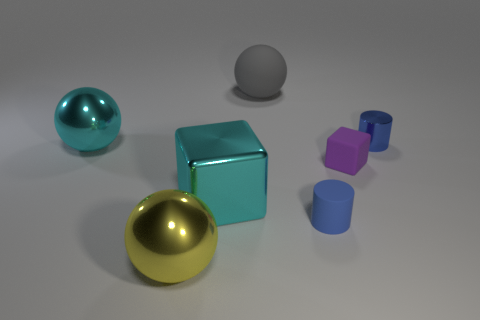Is there a small cylinder that has the same material as the purple block?
Your answer should be very brief. Yes. What is the shape of the yellow object?
Make the answer very short. Sphere. How many purple matte objects are there?
Offer a terse response. 1. What is the color of the tiny cylinder in front of the metal object on the right side of the big rubber object?
Provide a succinct answer. Blue. The rubber ball that is the same size as the cyan block is what color?
Give a very brief answer. Gray. Is there a small rubber cylinder that has the same color as the tiny metallic object?
Provide a succinct answer. Yes. Is there a blue shiny block?
Offer a terse response. No. There is a blue thing on the right side of the purple rubber block; what shape is it?
Provide a short and direct response. Cylinder. How many big spheres are both left of the gray matte ball and behind the big yellow sphere?
Provide a succinct answer. 1. How many other objects are there of the same size as the yellow metal object?
Make the answer very short. 3. 